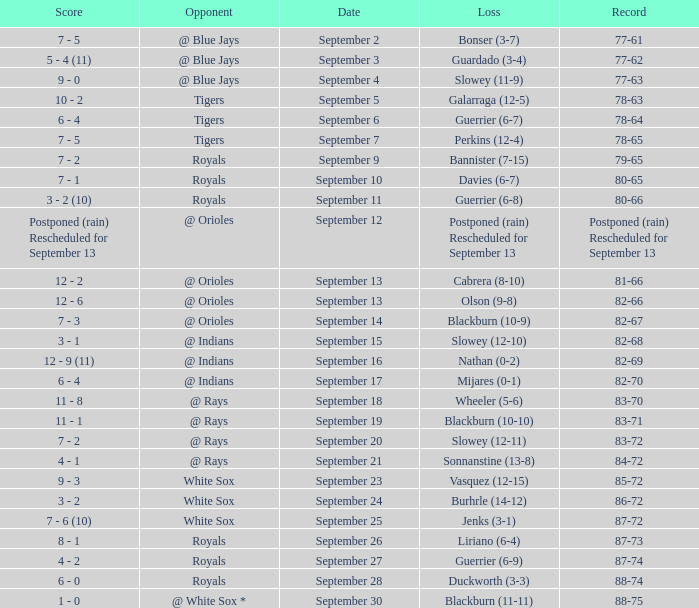What date has the record of 77-62? September 3. 